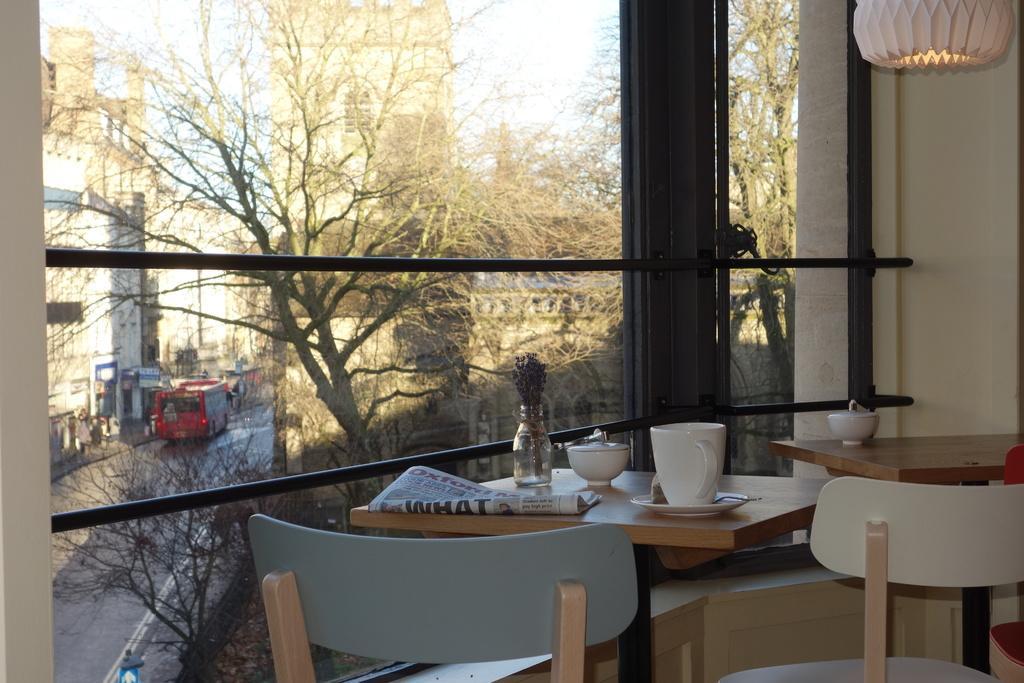Can you describe this image briefly? In this image we can see an inside view of a room. On the right side of the image we can see a group of chairs and tables. On the table we can see a group of cops and newspaper places, and a lamp. In the background, we can see a window, metal rods, group of trees, buildings, vehicle parked on the road and the sky. 